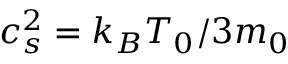Convert formula to latex. <formula><loc_0><loc_0><loc_500><loc_500>c _ { s } ^ { 2 } = k _ { B } T _ { 0 } / 3 m _ { 0 }</formula> 